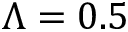<formula> <loc_0><loc_0><loc_500><loc_500>\Lambda = 0 . 5</formula> 